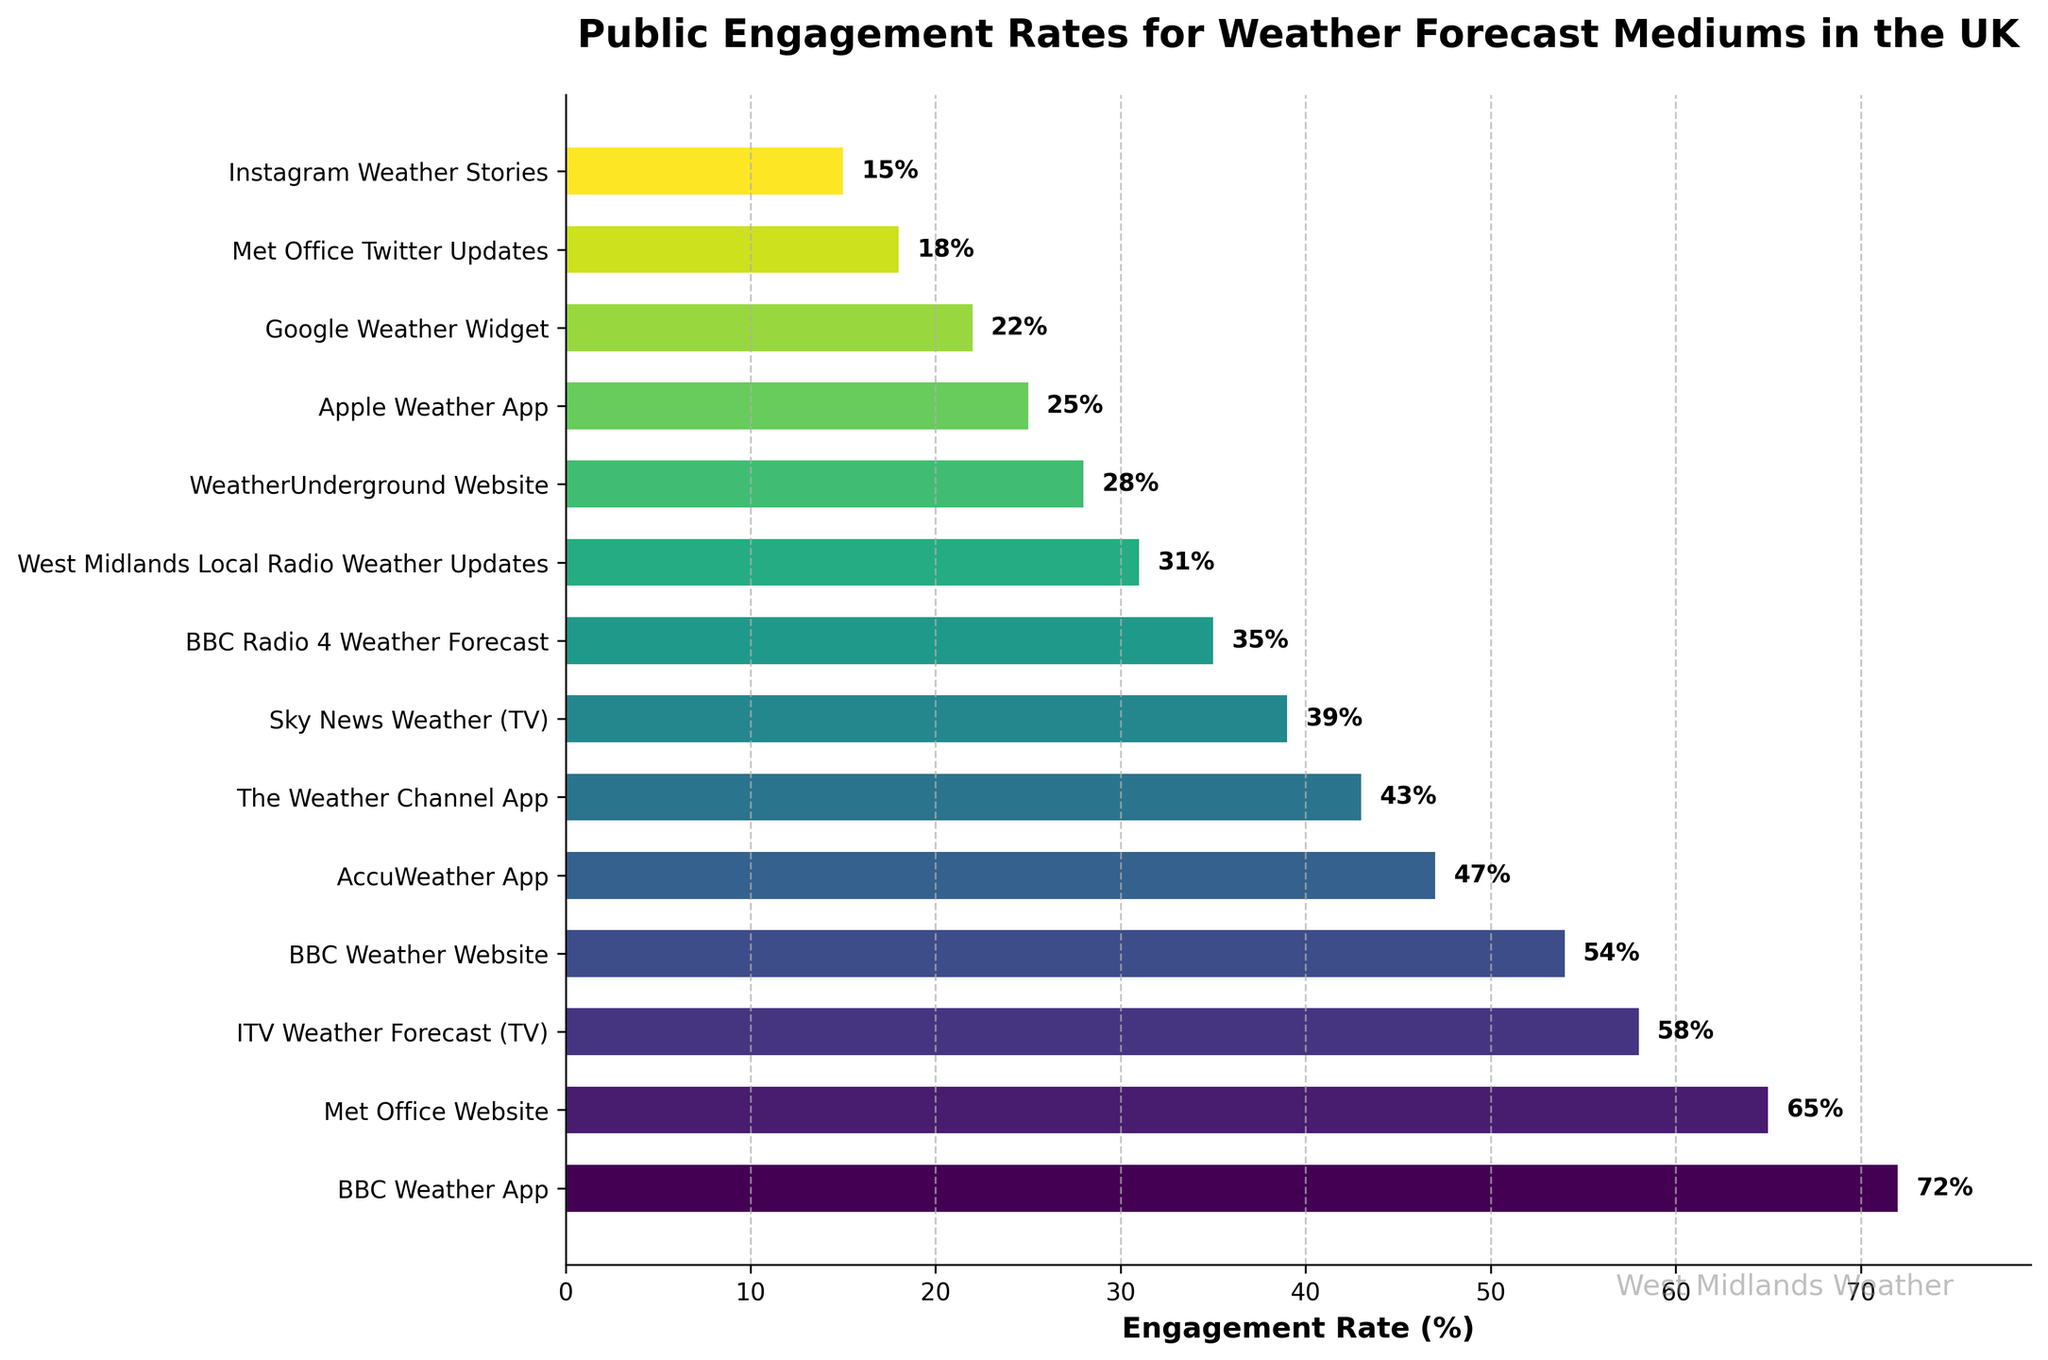What's the most popular medium for weather forecasts? The figure has a horizontal bar chart showing engagement rates, the bar representing "BBC Weather App" is the longest.
Answer: BBC Weather App Which medium has the lowest engagement rate? The figure displays engagement rates in descending order, the shortest bar corresponds to "Instagram Weather Stories".
Answer: Instagram Weather Stories How much higher is the engagement rate for the BBC Weather App compared to the Met Office Website? The engagement rate for the BBC Weather App is 72% and for the Met Office Website is 65%. Subtracting these gives 72% - 65% = 7%.
Answer: 7% Among the top three mediums, which one ranks third in terms of engagement rate? The top three bars represent "BBC Weather App" (72%), "Met Office Website" (65%), and "ITV Weather Forecast (TV)" (58%). The third in this order is "ITV Weather Forecast (TV)".
Answer: ITV Weather Forecast (TV) How many mediums have an engagement rate above 50%? By visually inspecting the chart and identifying bars that cross the 50% line, there are four mediums: "BBC Weather App", "Met Office Website", "ITV Weather Forecast (TV)", and "BBC Weather Website".
Answer: 4 What is the sum of the engagement rates for the three least popular mediums? The least popular mediums are "Apple Weather App" (25%), "Google Weather Widget" (22%), and "Instagram Weather Stories" (15%). Summing these values gives 25% + 22% + 15% = 62%.
Answer: 62% What is the difference in engagement rates between the most popular and least popular medium? The most popular medium is "BBC Weather App" with 72%, and the least popular is "Instagram Weather Stories" with 15%. The difference is 72% - 15% = 57%.
Answer: 57% Is the engagement rate of Met Office Twitter Updates higher than that of Instagram Weather Stories? The engagement rate of "Met Office Twitter Updates" is 18%, and that of "Instagram Weather Stories" is 15%, which is lower.
Answer: Yes Which app has a higher engagement rate, AccuWeather App or The Weather Channel App? By comparing the bar lengths in the figure, "AccuWeather App" has 47% and "The Weather Channel App" has 43%, thus AccuWeather App is higher.
Answer: AccuWeather App Calculate the average engagement rate of all the apps listed. The apps listed are "BBC Weather App" (72%), "AccuWeather App" (47%), "The Weather Channel App" (43%), "Apple Weather App" (25%), and "Google Weather Widget" (22%). The sum is 72 + 47 + 43 + 25 + 22 = 209. There are 5 apps, so the average is 209 / 5 = 41.8%.
Answer: 41.8% 